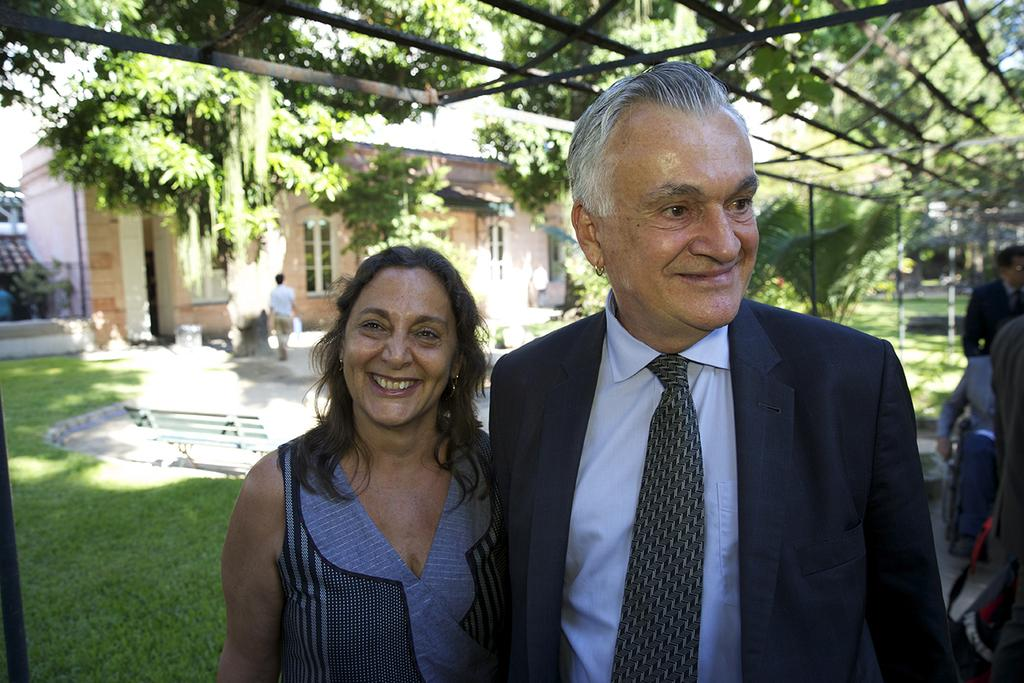How many people are in the image? There are two people in the image. What is the facial expression of the people in the image? The people are smiling. What can be seen in the background of the image? There is a bench, grass, people, trees, poles, and some objects visible in the background of the image. What type of pickle is being used as a weapon in the image? There is no pickle present in the image, and therefore no such activity can be observed. 